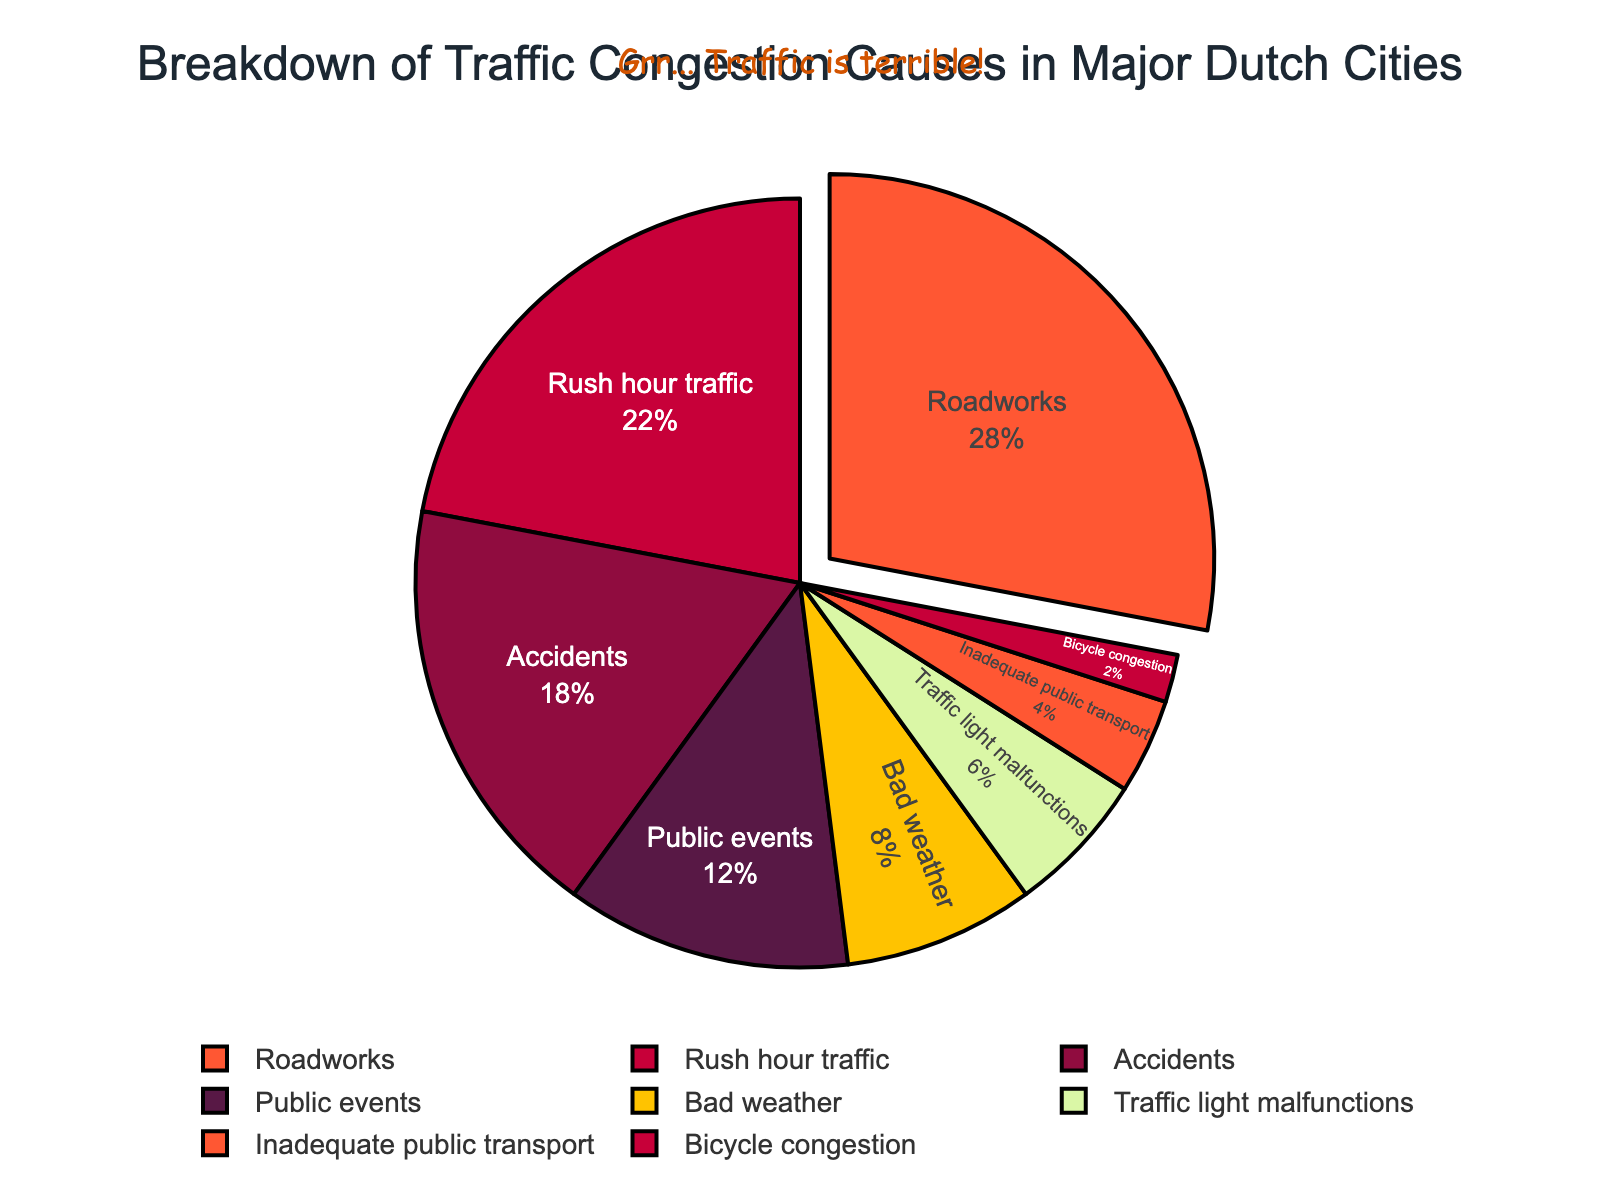What is the most common cause of traffic congestion in major Dutch cities? The pie chart shows that 'Roadworks' occupies the largest segment.
Answer: Roadworks How much more significant is 'Rush hour traffic' compared to 'Accidents' in terms of percentage? 'Rush hour traffic' accounts for 22%, while 'Accidents' account for 18%. The difference is 22 - 18 = 4%.
Answer: 4% What is the combined percentage of 'Public events' and 'Bad weather'? The percentages are: Public events = 12%, Bad weather = 8%. Combining these gives 12 + 8 = 20%.
Answer: 20% Which causes of traffic congestion are less significant than 'Accidents'? 'Accidents' account for 18%. The causes with lower percentages are 'Public events', 'Bad weather', 'Traffic light malfunctions', 'Inadequate public transport', and 'Bicycle congestion'.
Answer: Public events, Bad weather, Traffic light malfunctions, Inadequate public transport, Bicycle congestion How much less significant is 'Inadequate public transport' compared to 'Public events'? 'Inadequate public transport' accounts for 4%, while 'Public events' account for 12%. The difference is 12 - 4 = 8%.
Answer: 8% What is the total percentage for 'Roadworks', 'Rush hour traffic', and 'Accidents'? 'Roadworks' = 28%, 'Rush hour traffic' = 22%, 'Accidents' = 18%. Sum these up: 28 + 22 + 18 = 68%.
Answer: 68% Which cause of congestion is represented by the smallest segment in the pie chart? 'Bicycle congestion' occupies the smallest slice with 2%.
Answer: Bicycle congestion How does 'Traffic light malfunctions' compare visually to 'Bad weather' in the chart? 'Traffic light malfunctions' (6%) is a smaller segment than 'Bad weather' (8%). Visually, it's a smaller proportion of the pie.
Answer: Smaller Considering 'Public events' and 'Bad weather', how do their combined percentages compare to 'Roadworks'? 'Public events' = 12%, 'Bad weather' = 8%, so combined percentage is 12 + 8 = 20%. 'Roadworks' alone is 28%. Therefore, the combined percentage (20%) is less than 'Roadworks' (28%).
Answer: Less than 